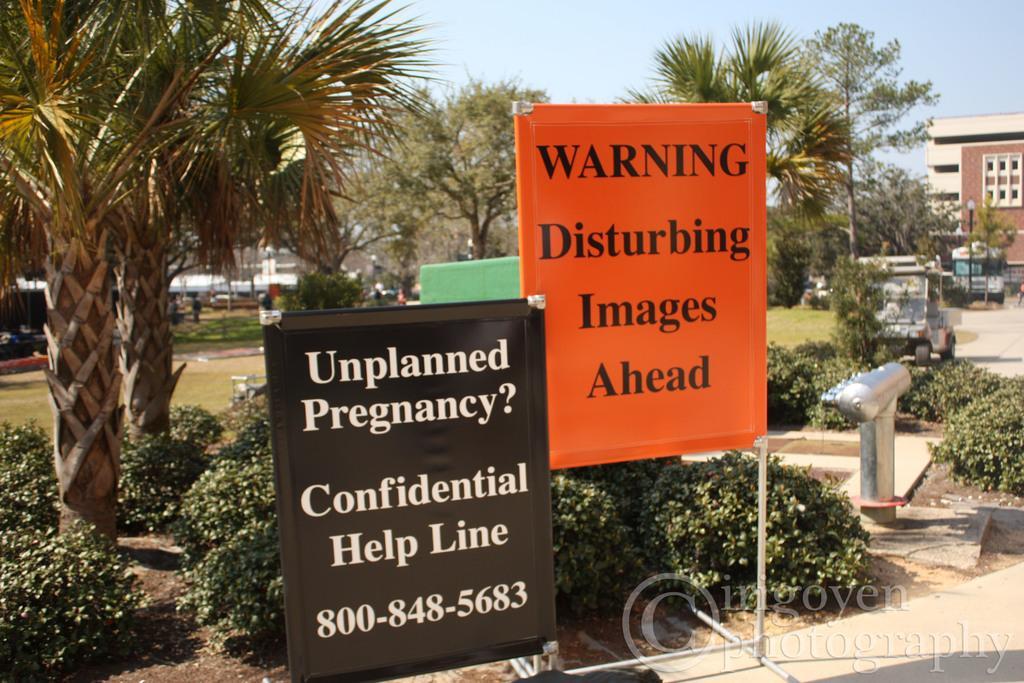Could you give a brief overview of what you see in this image? In this image in the front there are boards with some text written on it. In the center there are plants, trees and there's grass on the ground. In the background there are buildings, trees and there are vehicles. 